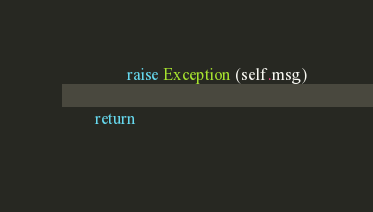<code> <loc_0><loc_0><loc_500><loc_500><_Python_>                raise Exception (self.msg) 

        return 
    </code> 